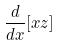<formula> <loc_0><loc_0><loc_500><loc_500>\frac { d } { d x } [ x z ]</formula> 